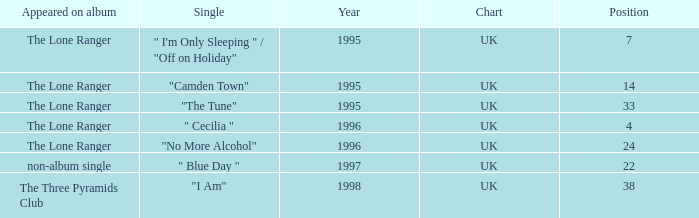After 1996, what is the average position? 30.0. 